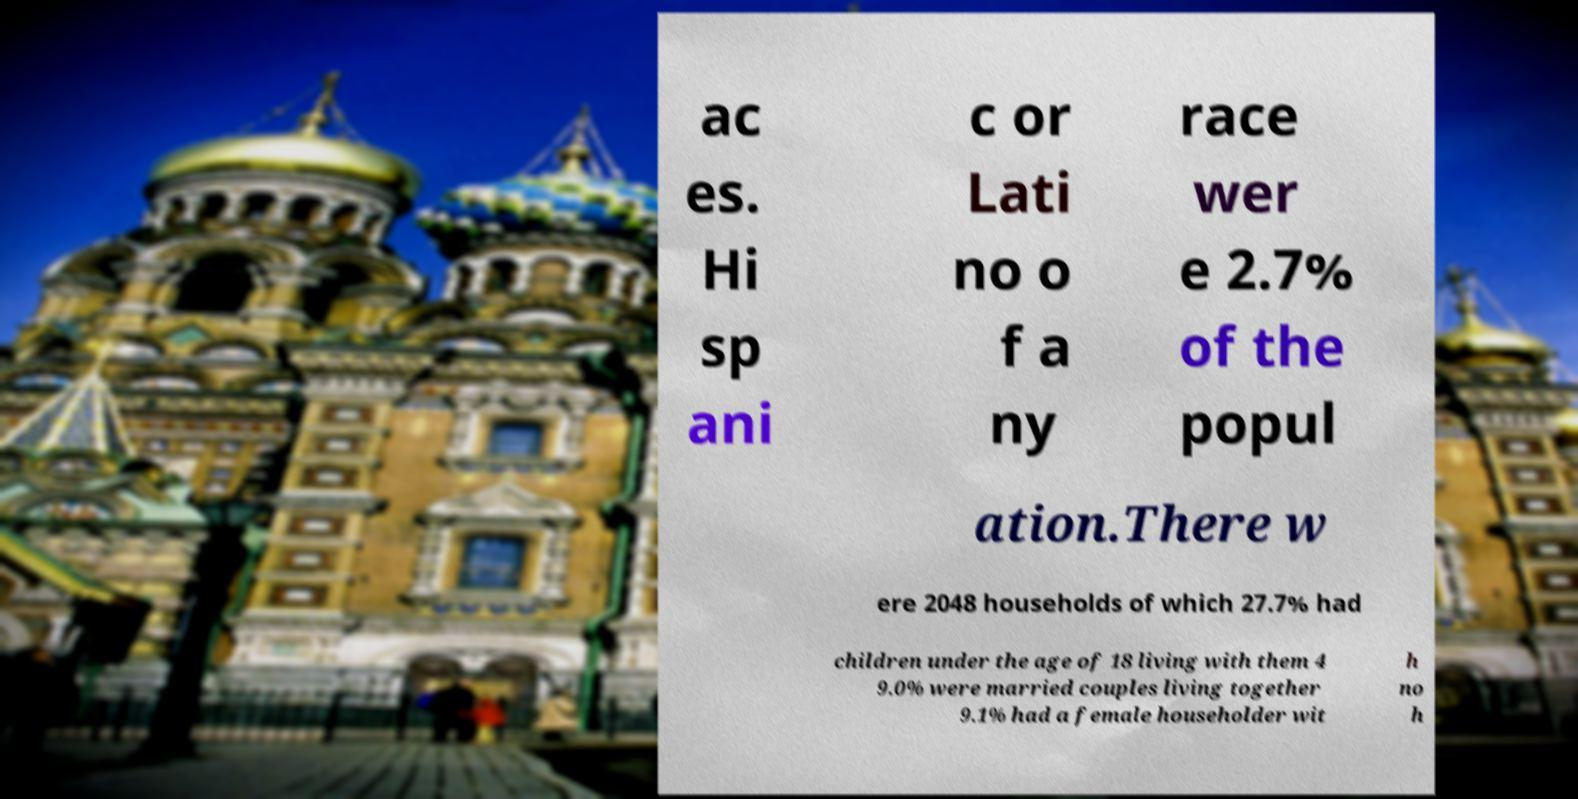Could you assist in decoding the text presented in this image and type it out clearly? ac es. Hi sp ani c or Lati no o f a ny race wer e 2.7% of the popul ation.There w ere 2048 households of which 27.7% had children under the age of 18 living with them 4 9.0% were married couples living together 9.1% had a female householder wit h no h 